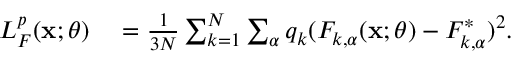Convert formula to latex. <formula><loc_0><loc_0><loc_500><loc_500>\begin{array} { r l } { L _ { F } ^ { p } ( x ; \theta ) } & = \frac { 1 } { 3 N } \sum _ { k = 1 } ^ { N } \sum _ { \alpha } q _ { k } ( F _ { k , \alpha } ( x ; \theta ) - F _ { k , \alpha } ^ { * } ) ^ { 2 } . } \end{array}</formula> 